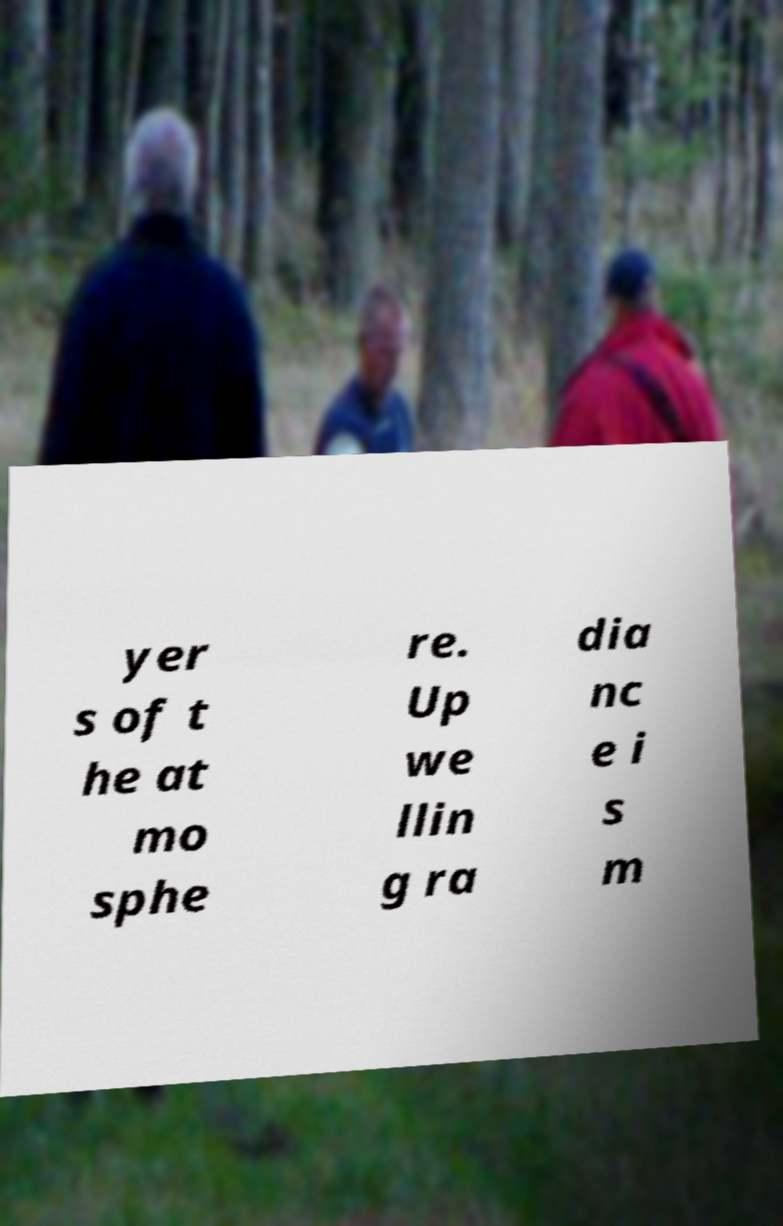Can you accurately transcribe the text from the provided image for me? yer s of t he at mo sphe re. Up we llin g ra dia nc e i s m 